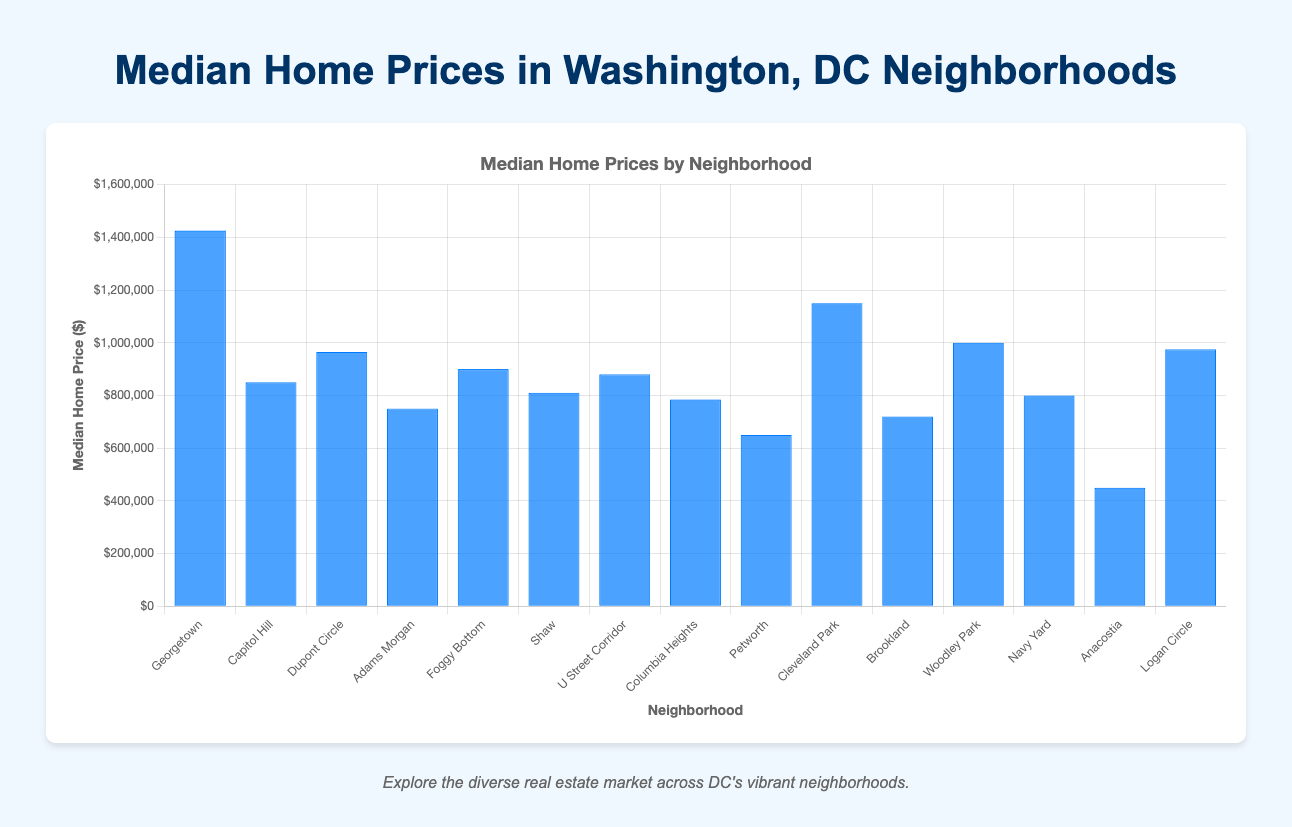Which neighborhood has the highest median home price? The tallest bar represents the highest median price. It is Georgetown.
Answer: Georgetown Which neighborhood has the lowest median home price? The shortest bar represents the lowest median price. It is Anacostia.
Answer: Anacostia How much higher is the median home price in Georgetown compared to Anacostia? Georgetown has a median home price of $1,425,000 and Anacostia has a median home price of $450,000. The difference is $1,425,000 - $450,000 = $975,000.
Answer: $975,000 What is the median home price in Logan Circle? Locate the bar labeled Logan Circle and read its height, which corresponds to $975,000.
Answer: $975,000 Which neighborhood has a median home price closest to $900,000? Look for bars near the $900,000 mark. Foggy Bottom and U Street Corridor are close, but Foggy Bottom is exactly $900,000.
Answer: Foggy Bottom Between Columbia Heights and Petworth, which has a higher median home price and by how much? Columbia Heights has a median home price of $785,000 while Petworth is $650,000. The difference is $785,000 - $650,000 = $135,000.
Answer: Columbia Heights by $135,000 What is the average median home price of Shaw, Navy Yard, and Dupont Circle? Sum their prices and divide by 3. Shaw: $810,000, Navy Yard: $800,000, Dupont Circle: $965,000. Average = ($810,000 + $800,000 + $965,000) / 3 ≈ $858,333.
Answer: $858,333 How many neighborhoods have a median home price over $1,000,000? Count the bars that surpass the $1,000,000 mark. They are Georgetown, Cleveland Park, and Woodley Park.
Answer: 3 What is the combined median home price for Capitol Hill, Adams Morgan, and Navy Yard? Sum the prices of these three neighborhoods. Capitol Hill: $850,000, Adams Morgan: $750,000, and Navy Yard: $800,000. Combined = $850,000 + $750,000 + $800,000 = $2,400,000.
Answer: $2,400,000 